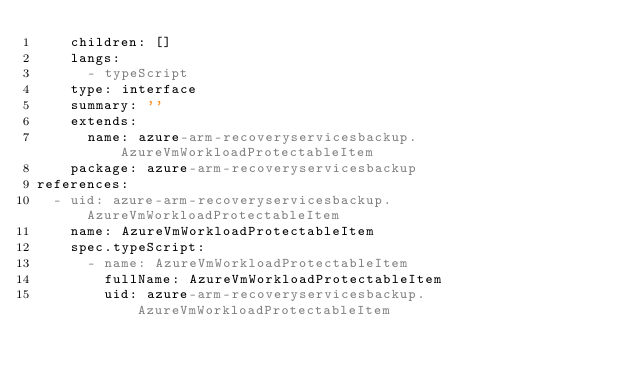Convert code to text. <code><loc_0><loc_0><loc_500><loc_500><_YAML_>    children: []
    langs:
      - typeScript
    type: interface
    summary: ''
    extends:
      name: azure-arm-recoveryservicesbackup.AzureVmWorkloadProtectableItem
    package: azure-arm-recoveryservicesbackup
references:
  - uid: azure-arm-recoveryservicesbackup.AzureVmWorkloadProtectableItem
    name: AzureVmWorkloadProtectableItem
    spec.typeScript:
      - name: AzureVmWorkloadProtectableItem
        fullName: AzureVmWorkloadProtectableItem
        uid: azure-arm-recoveryservicesbackup.AzureVmWorkloadProtectableItem
</code> 